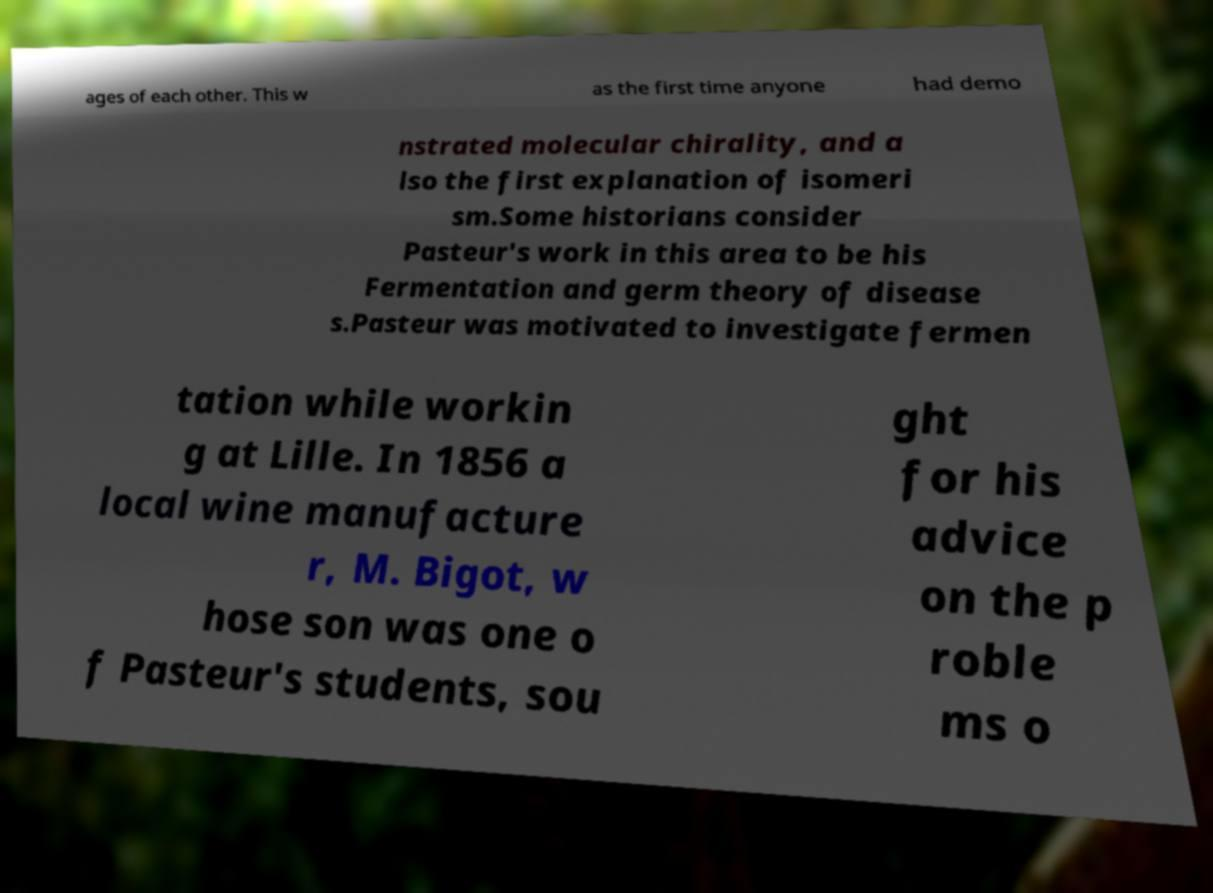I need the written content from this picture converted into text. Can you do that? ages of each other. This w as the first time anyone had demo nstrated molecular chirality, and a lso the first explanation of isomeri sm.Some historians consider Pasteur's work in this area to be his Fermentation and germ theory of disease s.Pasteur was motivated to investigate fermen tation while workin g at Lille. In 1856 a local wine manufacture r, M. Bigot, w hose son was one o f Pasteur's students, sou ght for his advice on the p roble ms o 